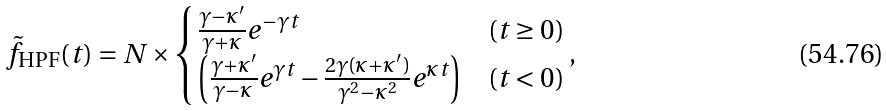Convert formula to latex. <formula><loc_0><loc_0><loc_500><loc_500>\tilde { f } _ { \text {HPF} } ( t ) = N \times \begin{cases} \frac { \gamma - \kappa ^ { \prime } } { \gamma + \kappa } e ^ { - \gamma t } & ( t \geq 0 ) \\ \left ( \frac { \gamma + \kappa ^ { \prime } } { \gamma - \kappa } e ^ { \gamma t } - \frac { 2 \gamma ( \kappa + \kappa ^ { \prime } ) } { \gamma ^ { 2 } - \kappa ^ { 2 } } e ^ { \kappa t } \right ) & ( t < 0 ) \end{cases} ,</formula> 